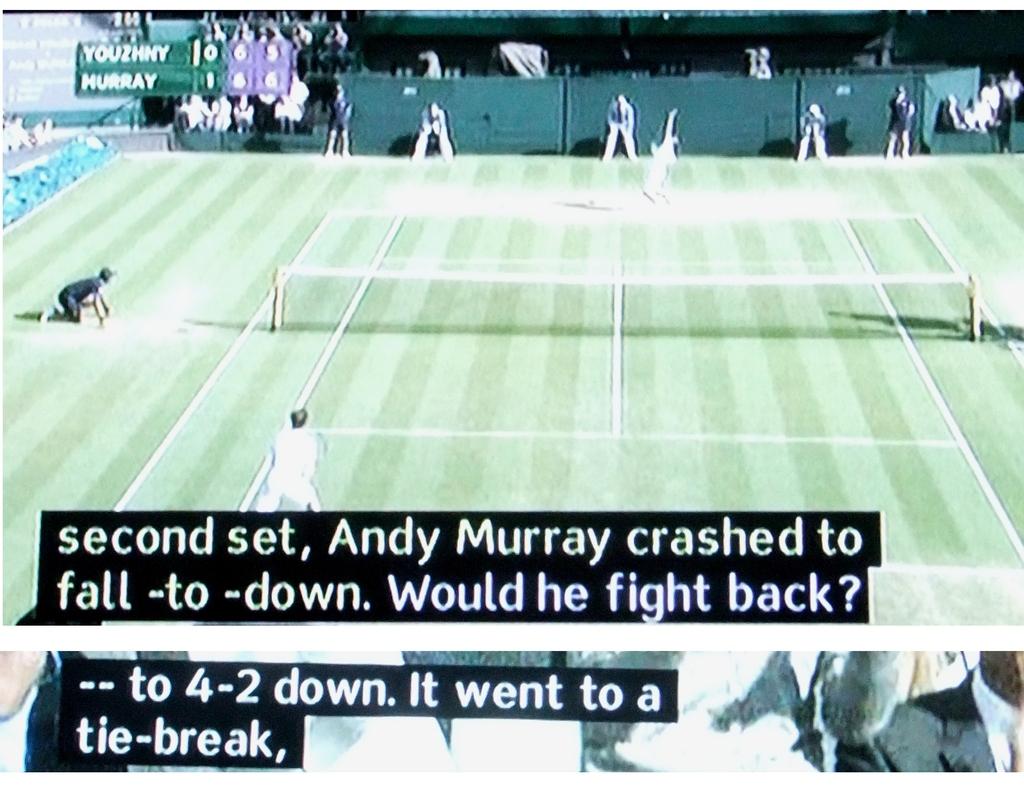What are the last names of the tennis players in the match?
Offer a terse response. Murray. What did it go to?
Keep it short and to the point. Tie-break. 